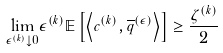Convert formula to latex. <formula><loc_0><loc_0><loc_500><loc_500>\underset { \epsilon ^ { ( k ) } \downarrow 0 } { \lim } \epsilon ^ { ( k ) } \mathbb { E } \left [ \left \langle c ^ { ( k ) } , \overline { q } ^ { ( \epsilon ) } \right \rangle \right ] \geq \frac { \zeta ^ { ( k ) } } { 2 }</formula> 